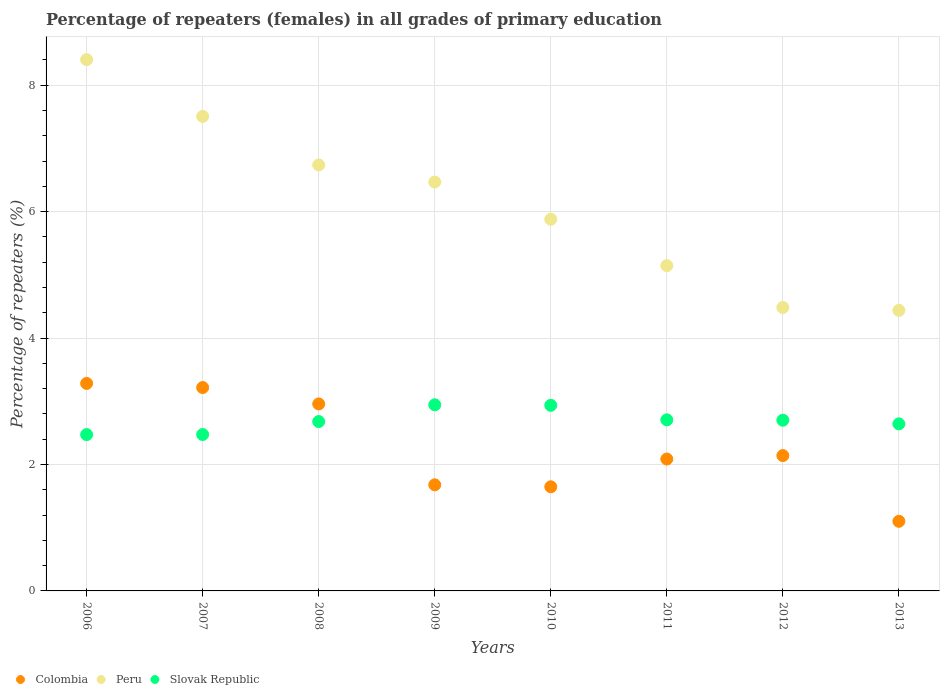How many different coloured dotlines are there?
Provide a short and direct response. 3. What is the percentage of repeaters (females) in Peru in 2008?
Your answer should be very brief. 6.74. Across all years, what is the maximum percentage of repeaters (females) in Slovak Republic?
Provide a short and direct response. 2.94. Across all years, what is the minimum percentage of repeaters (females) in Peru?
Your answer should be very brief. 4.44. In which year was the percentage of repeaters (females) in Peru minimum?
Provide a short and direct response. 2013. What is the total percentage of repeaters (females) in Colombia in the graph?
Make the answer very short. 18.11. What is the difference between the percentage of repeaters (females) in Colombia in 2006 and that in 2011?
Provide a short and direct response. 1.2. What is the difference between the percentage of repeaters (females) in Peru in 2011 and the percentage of repeaters (females) in Colombia in 2013?
Ensure brevity in your answer.  4.04. What is the average percentage of repeaters (females) in Peru per year?
Offer a terse response. 6.13. In the year 2008, what is the difference between the percentage of repeaters (females) in Colombia and percentage of repeaters (females) in Slovak Republic?
Give a very brief answer. 0.28. In how many years, is the percentage of repeaters (females) in Slovak Republic greater than 2.4 %?
Your answer should be very brief. 8. What is the ratio of the percentage of repeaters (females) in Slovak Republic in 2010 to that in 2011?
Offer a very short reply. 1.08. Is the percentage of repeaters (females) in Peru in 2007 less than that in 2008?
Offer a very short reply. No. Is the difference between the percentage of repeaters (females) in Colombia in 2006 and 2008 greater than the difference between the percentage of repeaters (females) in Slovak Republic in 2006 and 2008?
Offer a very short reply. Yes. What is the difference between the highest and the second highest percentage of repeaters (females) in Colombia?
Provide a short and direct response. 0.07. What is the difference between the highest and the lowest percentage of repeaters (females) in Colombia?
Give a very brief answer. 2.18. Is the sum of the percentage of repeaters (females) in Colombia in 2006 and 2013 greater than the maximum percentage of repeaters (females) in Slovak Republic across all years?
Your answer should be very brief. Yes. Is it the case that in every year, the sum of the percentage of repeaters (females) in Peru and percentage of repeaters (females) in Slovak Republic  is greater than the percentage of repeaters (females) in Colombia?
Offer a very short reply. Yes. Is the percentage of repeaters (females) in Peru strictly greater than the percentage of repeaters (females) in Colombia over the years?
Give a very brief answer. Yes. Is the percentage of repeaters (females) in Peru strictly less than the percentage of repeaters (females) in Slovak Republic over the years?
Ensure brevity in your answer.  No. How many dotlines are there?
Provide a succinct answer. 3. What is the difference between two consecutive major ticks on the Y-axis?
Ensure brevity in your answer.  2. What is the title of the graph?
Offer a terse response. Percentage of repeaters (females) in all grades of primary education. What is the label or title of the Y-axis?
Offer a terse response. Percentage of repeaters (%). What is the Percentage of repeaters (%) of Colombia in 2006?
Keep it short and to the point. 3.28. What is the Percentage of repeaters (%) of Peru in 2006?
Your answer should be very brief. 8.4. What is the Percentage of repeaters (%) in Slovak Republic in 2006?
Provide a succinct answer. 2.47. What is the Percentage of repeaters (%) in Colombia in 2007?
Your response must be concise. 3.22. What is the Percentage of repeaters (%) of Peru in 2007?
Your answer should be very brief. 7.51. What is the Percentage of repeaters (%) in Slovak Republic in 2007?
Provide a succinct answer. 2.47. What is the Percentage of repeaters (%) of Colombia in 2008?
Keep it short and to the point. 2.96. What is the Percentage of repeaters (%) in Peru in 2008?
Ensure brevity in your answer.  6.74. What is the Percentage of repeaters (%) of Slovak Republic in 2008?
Your answer should be very brief. 2.68. What is the Percentage of repeaters (%) in Colombia in 2009?
Make the answer very short. 1.68. What is the Percentage of repeaters (%) in Peru in 2009?
Your response must be concise. 6.47. What is the Percentage of repeaters (%) of Slovak Republic in 2009?
Your answer should be compact. 2.94. What is the Percentage of repeaters (%) in Colombia in 2010?
Offer a terse response. 1.65. What is the Percentage of repeaters (%) in Peru in 2010?
Give a very brief answer. 5.88. What is the Percentage of repeaters (%) of Slovak Republic in 2010?
Your answer should be very brief. 2.94. What is the Percentage of repeaters (%) in Colombia in 2011?
Keep it short and to the point. 2.09. What is the Percentage of repeaters (%) in Peru in 2011?
Your answer should be compact. 5.14. What is the Percentage of repeaters (%) of Slovak Republic in 2011?
Ensure brevity in your answer.  2.71. What is the Percentage of repeaters (%) of Colombia in 2012?
Offer a very short reply. 2.14. What is the Percentage of repeaters (%) of Peru in 2012?
Your answer should be very brief. 4.48. What is the Percentage of repeaters (%) in Slovak Republic in 2012?
Your answer should be very brief. 2.7. What is the Percentage of repeaters (%) of Colombia in 2013?
Keep it short and to the point. 1.1. What is the Percentage of repeaters (%) in Peru in 2013?
Your answer should be compact. 4.44. What is the Percentage of repeaters (%) in Slovak Republic in 2013?
Keep it short and to the point. 2.64. Across all years, what is the maximum Percentage of repeaters (%) in Colombia?
Provide a succinct answer. 3.28. Across all years, what is the maximum Percentage of repeaters (%) in Peru?
Provide a short and direct response. 8.4. Across all years, what is the maximum Percentage of repeaters (%) of Slovak Republic?
Your answer should be very brief. 2.94. Across all years, what is the minimum Percentage of repeaters (%) in Colombia?
Provide a short and direct response. 1.1. Across all years, what is the minimum Percentage of repeaters (%) of Peru?
Provide a succinct answer. 4.44. Across all years, what is the minimum Percentage of repeaters (%) in Slovak Republic?
Your answer should be very brief. 2.47. What is the total Percentage of repeaters (%) of Colombia in the graph?
Your response must be concise. 18.11. What is the total Percentage of repeaters (%) in Peru in the graph?
Your answer should be compact. 49.06. What is the total Percentage of repeaters (%) of Slovak Republic in the graph?
Make the answer very short. 21.55. What is the difference between the Percentage of repeaters (%) of Colombia in 2006 and that in 2007?
Offer a terse response. 0.07. What is the difference between the Percentage of repeaters (%) in Peru in 2006 and that in 2007?
Ensure brevity in your answer.  0.9. What is the difference between the Percentage of repeaters (%) of Slovak Republic in 2006 and that in 2007?
Your response must be concise. -0. What is the difference between the Percentage of repeaters (%) in Colombia in 2006 and that in 2008?
Ensure brevity in your answer.  0.32. What is the difference between the Percentage of repeaters (%) in Peru in 2006 and that in 2008?
Offer a very short reply. 1.67. What is the difference between the Percentage of repeaters (%) in Slovak Republic in 2006 and that in 2008?
Provide a short and direct response. -0.21. What is the difference between the Percentage of repeaters (%) in Colombia in 2006 and that in 2009?
Offer a very short reply. 1.6. What is the difference between the Percentage of repeaters (%) of Peru in 2006 and that in 2009?
Give a very brief answer. 1.94. What is the difference between the Percentage of repeaters (%) in Slovak Republic in 2006 and that in 2009?
Your response must be concise. -0.47. What is the difference between the Percentage of repeaters (%) in Colombia in 2006 and that in 2010?
Make the answer very short. 1.64. What is the difference between the Percentage of repeaters (%) of Peru in 2006 and that in 2010?
Offer a very short reply. 2.52. What is the difference between the Percentage of repeaters (%) of Slovak Republic in 2006 and that in 2010?
Provide a succinct answer. -0.46. What is the difference between the Percentage of repeaters (%) of Colombia in 2006 and that in 2011?
Give a very brief answer. 1.2. What is the difference between the Percentage of repeaters (%) of Peru in 2006 and that in 2011?
Keep it short and to the point. 3.26. What is the difference between the Percentage of repeaters (%) in Slovak Republic in 2006 and that in 2011?
Provide a succinct answer. -0.23. What is the difference between the Percentage of repeaters (%) in Colombia in 2006 and that in 2012?
Your answer should be compact. 1.14. What is the difference between the Percentage of repeaters (%) in Peru in 2006 and that in 2012?
Offer a terse response. 3.92. What is the difference between the Percentage of repeaters (%) in Slovak Republic in 2006 and that in 2012?
Your answer should be very brief. -0.23. What is the difference between the Percentage of repeaters (%) in Colombia in 2006 and that in 2013?
Keep it short and to the point. 2.18. What is the difference between the Percentage of repeaters (%) in Peru in 2006 and that in 2013?
Provide a short and direct response. 3.97. What is the difference between the Percentage of repeaters (%) in Slovak Republic in 2006 and that in 2013?
Give a very brief answer. -0.17. What is the difference between the Percentage of repeaters (%) of Colombia in 2007 and that in 2008?
Provide a short and direct response. 0.26. What is the difference between the Percentage of repeaters (%) in Peru in 2007 and that in 2008?
Your response must be concise. 0.77. What is the difference between the Percentage of repeaters (%) of Slovak Republic in 2007 and that in 2008?
Ensure brevity in your answer.  -0.2. What is the difference between the Percentage of repeaters (%) in Colombia in 2007 and that in 2009?
Keep it short and to the point. 1.54. What is the difference between the Percentage of repeaters (%) of Peru in 2007 and that in 2009?
Your answer should be compact. 1.04. What is the difference between the Percentage of repeaters (%) in Slovak Republic in 2007 and that in 2009?
Provide a short and direct response. -0.47. What is the difference between the Percentage of repeaters (%) of Colombia in 2007 and that in 2010?
Your answer should be very brief. 1.57. What is the difference between the Percentage of repeaters (%) of Peru in 2007 and that in 2010?
Your answer should be compact. 1.63. What is the difference between the Percentage of repeaters (%) of Slovak Republic in 2007 and that in 2010?
Provide a short and direct response. -0.46. What is the difference between the Percentage of repeaters (%) in Colombia in 2007 and that in 2011?
Your answer should be compact. 1.13. What is the difference between the Percentage of repeaters (%) of Peru in 2007 and that in 2011?
Ensure brevity in your answer.  2.36. What is the difference between the Percentage of repeaters (%) of Slovak Republic in 2007 and that in 2011?
Ensure brevity in your answer.  -0.23. What is the difference between the Percentage of repeaters (%) of Colombia in 2007 and that in 2012?
Your response must be concise. 1.08. What is the difference between the Percentage of repeaters (%) in Peru in 2007 and that in 2012?
Give a very brief answer. 3.02. What is the difference between the Percentage of repeaters (%) in Slovak Republic in 2007 and that in 2012?
Your answer should be compact. -0.23. What is the difference between the Percentage of repeaters (%) of Colombia in 2007 and that in 2013?
Your response must be concise. 2.12. What is the difference between the Percentage of repeaters (%) in Peru in 2007 and that in 2013?
Provide a succinct answer. 3.07. What is the difference between the Percentage of repeaters (%) in Slovak Republic in 2007 and that in 2013?
Your answer should be very brief. -0.17. What is the difference between the Percentage of repeaters (%) in Colombia in 2008 and that in 2009?
Offer a terse response. 1.28. What is the difference between the Percentage of repeaters (%) in Peru in 2008 and that in 2009?
Offer a very short reply. 0.27. What is the difference between the Percentage of repeaters (%) of Slovak Republic in 2008 and that in 2009?
Your answer should be very brief. -0.26. What is the difference between the Percentage of repeaters (%) of Colombia in 2008 and that in 2010?
Your response must be concise. 1.31. What is the difference between the Percentage of repeaters (%) in Peru in 2008 and that in 2010?
Provide a short and direct response. 0.86. What is the difference between the Percentage of repeaters (%) in Slovak Republic in 2008 and that in 2010?
Offer a very short reply. -0.26. What is the difference between the Percentage of repeaters (%) in Colombia in 2008 and that in 2011?
Provide a succinct answer. 0.87. What is the difference between the Percentage of repeaters (%) of Peru in 2008 and that in 2011?
Your response must be concise. 1.59. What is the difference between the Percentage of repeaters (%) of Slovak Republic in 2008 and that in 2011?
Give a very brief answer. -0.03. What is the difference between the Percentage of repeaters (%) of Colombia in 2008 and that in 2012?
Provide a succinct answer. 0.82. What is the difference between the Percentage of repeaters (%) of Peru in 2008 and that in 2012?
Offer a very short reply. 2.25. What is the difference between the Percentage of repeaters (%) in Slovak Republic in 2008 and that in 2012?
Provide a short and direct response. -0.02. What is the difference between the Percentage of repeaters (%) of Colombia in 2008 and that in 2013?
Your answer should be very brief. 1.86. What is the difference between the Percentage of repeaters (%) in Peru in 2008 and that in 2013?
Ensure brevity in your answer.  2.3. What is the difference between the Percentage of repeaters (%) of Slovak Republic in 2008 and that in 2013?
Offer a very short reply. 0.04. What is the difference between the Percentage of repeaters (%) in Colombia in 2009 and that in 2010?
Your answer should be very brief. 0.03. What is the difference between the Percentage of repeaters (%) in Peru in 2009 and that in 2010?
Your answer should be compact. 0.59. What is the difference between the Percentage of repeaters (%) in Slovak Republic in 2009 and that in 2010?
Your response must be concise. 0.01. What is the difference between the Percentage of repeaters (%) in Colombia in 2009 and that in 2011?
Offer a very short reply. -0.41. What is the difference between the Percentage of repeaters (%) of Peru in 2009 and that in 2011?
Your answer should be very brief. 1.32. What is the difference between the Percentage of repeaters (%) of Slovak Republic in 2009 and that in 2011?
Ensure brevity in your answer.  0.24. What is the difference between the Percentage of repeaters (%) of Colombia in 2009 and that in 2012?
Keep it short and to the point. -0.46. What is the difference between the Percentage of repeaters (%) in Peru in 2009 and that in 2012?
Offer a very short reply. 1.98. What is the difference between the Percentage of repeaters (%) of Slovak Republic in 2009 and that in 2012?
Keep it short and to the point. 0.24. What is the difference between the Percentage of repeaters (%) of Colombia in 2009 and that in 2013?
Make the answer very short. 0.58. What is the difference between the Percentage of repeaters (%) in Peru in 2009 and that in 2013?
Your answer should be very brief. 2.03. What is the difference between the Percentage of repeaters (%) of Slovak Republic in 2009 and that in 2013?
Keep it short and to the point. 0.3. What is the difference between the Percentage of repeaters (%) of Colombia in 2010 and that in 2011?
Provide a succinct answer. -0.44. What is the difference between the Percentage of repeaters (%) in Peru in 2010 and that in 2011?
Your answer should be compact. 0.73. What is the difference between the Percentage of repeaters (%) in Slovak Republic in 2010 and that in 2011?
Keep it short and to the point. 0.23. What is the difference between the Percentage of repeaters (%) in Colombia in 2010 and that in 2012?
Make the answer very short. -0.49. What is the difference between the Percentage of repeaters (%) in Peru in 2010 and that in 2012?
Keep it short and to the point. 1.4. What is the difference between the Percentage of repeaters (%) in Slovak Republic in 2010 and that in 2012?
Give a very brief answer. 0.24. What is the difference between the Percentage of repeaters (%) of Colombia in 2010 and that in 2013?
Ensure brevity in your answer.  0.55. What is the difference between the Percentage of repeaters (%) in Peru in 2010 and that in 2013?
Keep it short and to the point. 1.44. What is the difference between the Percentage of repeaters (%) in Slovak Republic in 2010 and that in 2013?
Provide a succinct answer. 0.29. What is the difference between the Percentage of repeaters (%) of Colombia in 2011 and that in 2012?
Ensure brevity in your answer.  -0.05. What is the difference between the Percentage of repeaters (%) of Peru in 2011 and that in 2012?
Offer a terse response. 0.66. What is the difference between the Percentage of repeaters (%) of Slovak Republic in 2011 and that in 2012?
Offer a terse response. 0.01. What is the difference between the Percentage of repeaters (%) of Peru in 2011 and that in 2013?
Provide a short and direct response. 0.71. What is the difference between the Percentage of repeaters (%) in Slovak Republic in 2011 and that in 2013?
Keep it short and to the point. 0.06. What is the difference between the Percentage of repeaters (%) in Colombia in 2012 and that in 2013?
Your response must be concise. 1.04. What is the difference between the Percentage of repeaters (%) of Peru in 2012 and that in 2013?
Keep it short and to the point. 0.05. What is the difference between the Percentage of repeaters (%) of Slovak Republic in 2012 and that in 2013?
Your answer should be very brief. 0.06. What is the difference between the Percentage of repeaters (%) of Colombia in 2006 and the Percentage of repeaters (%) of Peru in 2007?
Ensure brevity in your answer.  -4.22. What is the difference between the Percentage of repeaters (%) of Colombia in 2006 and the Percentage of repeaters (%) of Slovak Republic in 2007?
Provide a succinct answer. 0.81. What is the difference between the Percentage of repeaters (%) of Peru in 2006 and the Percentage of repeaters (%) of Slovak Republic in 2007?
Provide a short and direct response. 5.93. What is the difference between the Percentage of repeaters (%) in Colombia in 2006 and the Percentage of repeaters (%) in Peru in 2008?
Ensure brevity in your answer.  -3.46. What is the difference between the Percentage of repeaters (%) of Colombia in 2006 and the Percentage of repeaters (%) of Slovak Republic in 2008?
Your response must be concise. 0.6. What is the difference between the Percentage of repeaters (%) in Peru in 2006 and the Percentage of repeaters (%) in Slovak Republic in 2008?
Keep it short and to the point. 5.72. What is the difference between the Percentage of repeaters (%) of Colombia in 2006 and the Percentage of repeaters (%) of Peru in 2009?
Offer a terse response. -3.19. What is the difference between the Percentage of repeaters (%) in Colombia in 2006 and the Percentage of repeaters (%) in Slovak Republic in 2009?
Give a very brief answer. 0.34. What is the difference between the Percentage of repeaters (%) in Peru in 2006 and the Percentage of repeaters (%) in Slovak Republic in 2009?
Provide a short and direct response. 5.46. What is the difference between the Percentage of repeaters (%) in Colombia in 2006 and the Percentage of repeaters (%) in Peru in 2010?
Make the answer very short. -2.6. What is the difference between the Percentage of repeaters (%) in Colombia in 2006 and the Percentage of repeaters (%) in Slovak Republic in 2010?
Make the answer very short. 0.35. What is the difference between the Percentage of repeaters (%) of Peru in 2006 and the Percentage of repeaters (%) of Slovak Republic in 2010?
Provide a succinct answer. 5.47. What is the difference between the Percentage of repeaters (%) of Colombia in 2006 and the Percentage of repeaters (%) of Peru in 2011?
Provide a short and direct response. -1.86. What is the difference between the Percentage of repeaters (%) in Colombia in 2006 and the Percentage of repeaters (%) in Slovak Republic in 2011?
Your answer should be compact. 0.58. What is the difference between the Percentage of repeaters (%) in Peru in 2006 and the Percentage of repeaters (%) in Slovak Republic in 2011?
Keep it short and to the point. 5.7. What is the difference between the Percentage of repeaters (%) in Colombia in 2006 and the Percentage of repeaters (%) in Peru in 2012?
Your response must be concise. -1.2. What is the difference between the Percentage of repeaters (%) of Colombia in 2006 and the Percentage of repeaters (%) of Slovak Republic in 2012?
Keep it short and to the point. 0.58. What is the difference between the Percentage of repeaters (%) of Peru in 2006 and the Percentage of repeaters (%) of Slovak Republic in 2012?
Keep it short and to the point. 5.7. What is the difference between the Percentage of repeaters (%) of Colombia in 2006 and the Percentage of repeaters (%) of Peru in 2013?
Offer a terse response. -1.16. What is the difference between the Percentage of repeaters (%) of Colombia in 2006 and the Percentage of repeaters (%) of Slovak Republic in 2013?
Provide a short and direct response. 0.64. What is the difference between the Percentage of repeaters (%) of Peru in 2006 and the Percentage of repeaters (%) of Slovak Republic in 2013?
Provide a short and direct response. 5.76. What is the difference between the Percentage of repeaters (%) in Colombia in 2007 and the Percentage of repeaters (%) in Peru in 2008?
Your answer should be very brief. -3.52. What is the difference between the Percentage of repeaters (%) in Colombia in 2007 and the Percentage of repeaters (%) in Slovak Republic in 2008?
Offer a terse response. 0.54. What is the difference between the Percentage of repeaters (%) in Peru in 2007 and the Percentage of repeaters (%) in Slovak Republic in 2008?
Provide a succinct answer. 4.83. What is the difference between the Percentage of repeaters (%) of Colombia in 2007 and the Percentage of repeaters (%) of Peru in 2009?
Provide a succinct answer. -3.25. What is the difference between the Percentage of repeaters (%) of Colombia in 2007 and the Percentage of repeaters (%) of Slovak Republic in 2009?
Make the answer very short. 0.27. What is the difference between the Percentage of repeaters (%) in Peru in 2007 and the Percentage of repeaters (%) in Slovak Republic in 2009?
Give a very brief answer. 4.56. What is the difference between the Percentage of repeaters (%) in Colombia in 2007 and the Percentage of repeaters (%) in Peru in 2010?
Provide a succinct answer. -2.66. What is the difference between the Percentage of repeaters (%) in Colombia in 2007 and the Percentage of repeaters (%) in Slovak Republic in 2010?
Offer a very short reply. 0.28. What is the difference between the Percentage of repeaters (%) of Peru in 2007 and the Percentage of repeaters (%) of Slovak Republic in 2010?
Your answer should be compact. 4.57. What is the difference between the Percentage of repeaters (%) of Colombia in 2007 and the Percentage of repeaters (%) of Peru in 2011?
Make the answer very short. -1.93. What is the difference between the Percentage of repeaters (%) in Colombia in 2007 and the Percentage of repeaters (%) in Slovak Republic in 2011?
Provide a short and direct response. 0.51. What is the difference between the Percentage of repeaters (%) of Peru in 2007 and the Percentage of repeaters (%) of Slovak Republic in 2011?
Provide a succinct answer. 4.8. What is the difference between the Percentage of repeaters (%) of Colombia in 2007 and the Percentage of repeaters (%) of Peru in 2012?
Provide a succinct answer. -1.27. What is the difference between the Percentage of repeaters (%) in Colombia in 2007 and the Percentage of repeaters (%) in Slovak Republic in 2012?
Give a very brief answer. 0.52. What is the difference between the Percentage of repeaters (%) of Peru in 2007 and the Percentage of repeaters (%) of Slovak Republic in 2012?
Provide a succinct answer. 4.81. What is the difference between the Percentage of repeaters (%) in Colombia in 2007 and the Percentage of repeaters (%) in Peru in 2013?
Give a very brief answer. -1.22. What is the difference between the Percentage of repeaters (%) in Colombia in 2007 and the Percentage of repeaters (%) in Slovak Republic in 2013?
Make the answer very short. 0.57. What is the difference between the Percentage of repeaters (%) in Peru in 2007 and the Percentage of repeaters (%) in Slovak Republic in 2013?
Make the answer very short. 4.86. What is the difference between the Percentage of repeaters (%) of Colombia in 2008 and the Percentage of repeaters (%) of Peru in 2009?
Your answer should be compact. -3.51. What is the difference between the Percentage of repeaters (%) in Colombia in 2008 and the Percentage of repeaters (%) in Slovak Republic in 2009?
Provide a succinct answer. 0.01. What is the difference between the Percentage of repeaters (%) of Peru in 2008 and the Percentage of repeaters (%) of Slovak Republic in 2009?
Your answer should be compact. 3.79. What is the difference between the Percentage of repeaters (%) in Colombia in 2008 and the Percentage of repeaters (%) in Peru in 2010?
Provide a short and direct response. -2.92. What is the difference between the Percentage of repeaters (%) of Colombia in 2008 and the Percentage of repeaters (%) of Slovak Republic in 2010?
Ensure brevity in your answer.  0.02. What is the difference between the Percentage of repeaters (%) of Peru in 2008 and the Percentage of repeaters (%) of Slovak Republic in 2010?
Provide a short and direct response. 3.8. What is the difference between the Percentage of repeaters (%) of Colombia in 2008 and the Percentage of repeaters (%) of Peru in 2011?
Provide a succinct answer. -2.19. What is the difference between the Percentage of repeaters (%) of Colombia in 2008 and the Percentage of repeaters (%) of Slovak Republic in 2011?
Ensure brevity in your answer.  0.25. What is the difference between the Percentage of repeaters (%) in Peru in 2008 and the Percentage of repeaters (%) in Slovak Republic in 2011?
Make the answer very short. 4.03. What is the difference between the Percentage of repeaters (%) in Colombia in 2008 and the Percentage of repeaters (%) in Peru in 2012?
Offer a terse response. -1.53. What is the difference between the Percentage of repeaters (%) of Colombia in 2008 and the Percentage of repeaters (%) of Slovak Republic in 2012?
Your response must be concise. 0.26. What is the difference between the Percentage of repeaters (%) in Peru in 2008 and the Percentage of repeaters (%) in Slovak Republic in 2012?
Your response must be concise. 4.04. What is the difference between the Percentage of repeaters (%) of Colombia in 2008 and the Percentage of repeaters (%) of Peru in 2013?
Provide a short and direct response. -1.48. What is the difference between the Percentage of repeaters (%) in Colombia in 2008 and the Percentage of repeaters (%) in Slovak Republic in 2013?
Provide a succinct answer. 0.32. What is the difference between the Percentage of repeaters (%) of Peru in 2008 and the Percentage of repeaters (%) of Slovak Republic in 2013?
Your answer should be compact. 4.09. What is the difference between the Percentage of repeaters (%) of Colombia in 2009 and the Percentage of repeaters (%) of Peru in 2010?
Offer a terse response. -4.2. What is the difference between the Percentage of repeaters (%) in Colombia in 2009 and the Percentage of repeaters (%) in Slovak Republic in 2010?
Your answer should be compact. -1.26. What is the difference between the Percentage of repeaters (%) of Peru in 2009 and the Percentage of repeaters (%) of Slovak Republic in 2010?
Keep it short and to the point. 3.53. What is the difference between the Percentage of repeaters (%) of Colombia in 2009 and the Percentage of repeaters (%) of Peru in 2011?
Offer a very short reply. -3.47. What is the difference between the Percentage of repeaters (%) in Colombia in 2009 and the Percentage of repeaters (%) in Slovak Republic in 2011?
Give a very brief answer. -1.03. What is the difference between the Percentage of repeaters (%) of Peru in 2009 and the Percentage of repeaters (%) of Slovak Republic in 2011?
Offer a very short reply. 3.76. What is the difference between the Percentage of repeaters (%) in Colombia in 2009 and the Percentage of repeaters (%) in Peru in 2012?
Give a very brief answer. -2.8. What is the difference between the Percentage of repeaters (%) in Colombia in 2009 and the Percentage of repeaters (%) in Slovak Republic in 2012?
Offer a terse response. -1.02. What is the difference between the Percentage of repeaters (%) in Peru in 2009 and the Percentage of repeaters (%) in Slovak Republic in 2012?
Offer a terse response. 3.77. What is the difference between the Percentage of repeaters (%) in Colombia in 2009 and the Percentage of repeaters (%) in Peru in 2013?
Offer a very short reply. -2.76. What is the difference between the Percentage of repeaters (%) in Colombia in 2009 and the Percentage of repeaters (%) in Slovak Republic in 2013?
Offer a very short reply. -0.96. What is the difference between the Percentage of repeaters (%) in Peru in 2009 and the Percentage of repeaters (%) in Slovak Republic in 2013?
Your answer should be very brief. 3.82. What is the difference between the Percentage of repeaters (%) in Colombia in 2010 and the Percentage of repeaters (%) in Peru in 2011?
Provide a succinct answer. -3.5. What is the difference between the Percentage of repeaters (%) of Colombia in 2010 and the Percentage of repeaters (%) of Slovak Republic in 2011?
Provide a succinct answer. -1.06. What is the difference between the Percentage of repeaters (%) of Peru in 2010 and the Percentage of repeaters (%) of Slovak Republic in 2011?
Ensure brevity in your answer.  3.17. What is the difference between the Percentage of repeaters (%) in Colombia in 2010 and the Percentage of repeaters (%) in Peru in 2012?
Ensure brevity in your answer.  -2.84. What is the difference between the Percentage of repeaters (%) of Colombia in 2010 and the Percentage of repeaters (%) of Slovak Republic in 2012?
Provide a succinct answer. -1.05. What is the difference between the Percentage of repeaters (%) in Peru in 2010 and the Percentage of repeaters (%) in Slovak Republic in 2012?
Ensure brevity in your answer.  3.18. What is the difference between the Percentage of repeaters (%) in Colombia in 2010 and the Percentage of repeaters (%) in Peru in 2013?
Your response must be concise. -2.79. What is the difference between the Percentage of repeaters (%) in Colombia in 2010 and the Percentage of repeaters (%) in Slovak Republic in 2013?
Your answer should be compact. -1. What is the difference between the Percentage of repeaters (%) of Peru in 2010 and the Percentage of repeaters (%) of Slovak Republic in 2013?
Your response must be concise. 3.24. What is the difference between the Percentage of repeaters (%) of Colombia in 2011 and the Percentage of repeaters (%) of Peru in 2012?
Give a very brief answer. -2.4. What is the difference between the Percentage of repeaters (%) in Colombia in 2011 and the Percentage of repeaters (%) in Slovak Republic in 2012?
Your answer should be compact. -0.61. What is the difference between the Percentage of repeaters (%) in Peru in 2011 and the Percentage of repeaters (%) in Slovak Republic in 2012?
Your answer should be very brief. 2.44. What is the difference between the Percentage of repeaters (%) in Colombia in 2011 and the Percentage of repeaters (%) in Peru in 2013?
Your answer should be compact. -2.35. What is the difference between the Percentage of repeaters (%) in Colombia in 2011 and the Percentage of repeaters (%) in Slovak Republic in 2013?
Your response must be concise. -0.56. What is the difference between the Percentage of repeaters (%) in Peru in 2011 and the Percentage of repeaters (%) in Slovak Republic in 2013?
Provide a short and direct response. 2.5. What is the difference between the Percentage of repeaters (%) in Colombia in 2012 and the Percentage of repeaters (%) in Peru in 2013?
Ensure brevity in your answer.  -2.3. What is the difference between the Percentage of repeaters (%) in Colombia in 2012 and the Percentage of repeaters (%) in Slovak Republic in 2013?
Ensure brevity in your answer.  -0.5. What is the difference between the Percentage of repeaters (%) of Peru in 2012 and the Percentage of repeaters (%) of Slovak Republic in 2013?
Give a very brief answer. 1.84. What is the average Percentage of repeaters (%) in Colombia per year?
Provide a short and direct response. 2.26. What is the average Percentage of repeaters (%) in Peru per year?
Your response must be concise. 6.13. What is the average Percentage of repeaters (%) in Slovak Republic per year?
Offer a terse response. 2.69. In the year 2006, what is the difference between the Percentage of repeaters (%) of Colombia and Percentage of repeaters (%) of Peru?
Offer a very short reply. -5.12. In the year 2006, what is the difference between the Percentage of repeaters (%) in Colombia and Percentage of repeaters (%) in Slovak Republic?
Give a very brief answer. 0.81. In the year 2006, what is the difference between the Percentage of repeaters (%) in Peru and Percentage of repeaters (%) in Slovak Republic?
Keep it short and to the point. 5.93. In the year 2007, what is the difference between the Percentage of repeaters (%) in Colombia and Percentage of repeaters (%) in Peru?
Keep it short and to the point. -4.29. In the year 2007, what is the difference between the Percentage of repeaters (%) of Colombia and Percentage of repeaters (%) of Slovak Republic?
Your answer should be very brief. 0.74. In the year 2007, what is the difference between the Percentage of repeaters (%) of Peru and Percentage of repeaters (%) of Slovak Republic?
Your answer should be very brief. 5.03. In the year 2008, what is the difference between the Percentage of repeaters (%) of Colombia and Percentage of repeaters (%) of Peru?
Give a very brief answer. -3.78. In the year 2008, what is the difference between the Percentage of repeaters (%) of Colombia and Percentage of repeaters (%) of Slovak Republic?
Give a very brief answer. 0.28. In the year 2008, what is the difference between the Percentage of repeaters (%) of Peru and Percentage of repeaters (%) of Slovak Republic?
Provide a short and direct response. 4.06. In the year 2009, what is the difference between the Percentage of repeaters (%) in Colombia and Percentage of repeaters (%) in Peru?
Offer a terse response. -4.79. In the year 2009, what is the difference between the Percentage of repeaters (%) in Colombia and Percentage of repeaters (%) in Slovak Republic?
Your answer should be compact. -1.27. In the year 2009, what is the difference between the Percentage of repeaters (%) of Peru and Percentage of repeaters (%) of Slovak Republic?
Your answer should be very brief. 3.52. In the year 2010, what is the difference between the Percentage of repeaters (%) in Colombia and Percentage of repeaters (%) in Peru?
Your response must be concise. -4.23. In the year 2010, what is the difference between the Percentage of repeaters (%) of Colombia and Percentage of repeaters (%) of Slovak Republic?
Your answer should be very brief. -1.29. In the year 2010, what is the difference between the Percentage of repeaters (%) of Peru and Percentage of repeaters (%) of Slovak Republic?
Keep it short and to the point. 2.94. In the year 2011, what is the difference between the Percentage of repeaters (%) of Colombia and Percentage of repeaters (%) of Peru?
Provide a short and direct response. -3.06. In the year 2011, what is the difference between the Percentage of repeaters (%) of Colombia and Percentage of repeaters (%) of Slovak Republic?
Offer a very short reply. -0.62. In the year 2011, what is the difference between the Percentage of repeaters (%) of Peru and Percentage of repeaters (%) of Slovak Republic?
Offer a very short reply. 2.44. In the year 2012, what is the difference between the Percentage of repeaters (%) of Colombia and Percentage of repeaters (%) of Peru?
Give a very brief answer. -2.34. In the year 2012, what is the difference between the Percentage of repeaters (%) in Colombia and Percentage of repeaters (%) in Slovak Republic?
Give a very brief answer. -0.56. In the year 2012, what is the difference between the Percentage of repeaters (%) of Peru and Percentage of repeaters (%) of Slovak Republic?
Keep it short and to the point. 1.78. In the year 2013, what is the difference between the Percentage of repeaters (%) in Colombia and Percentage of repeaters (%) in Peru?
Offer a terse response. -3.34. In the year 2013, what is the difference between the Percentage of repeaters (%) of Colombia and Percentage of repeaters (%) of Slovak Republic?
Give a very brief answer. -1.54. In the year 2013, what is the difference between the Percentage of repeaters (%) of Peru and Percentage of repeaters (%) of Slovak Republic?
Provide a short and direct response. 1.8. What is the ratio of the Percentage of repeaters (%) of Colombia in 2006 to that in 2007?
Ensure brevity in your answer.  1.02. What is the ratio of the Percentage of repeaters (%) of Peru in 2006 to that in 2007?
Make the answer very short. 1.12. What is the ratio of the Percentage of repeaters (%) of Colombia in 2006 to that in 2008?
Make the answer very short. 1.11. What is the ratio of the Percentage of repeaters (%) in Peru in 2006 to that in 2008?
Your answer should be very brief. 1.25. What is the ratio of the Percentage of repeaters (%) in Slovak Republic in 2006 to that in 2008?
Make the answer very short. 0.92. What is the ratio of the Percentage of repeaters (%) of Colombia in 2006 to that in 2009?
Offer a very short reply. 1.96. What is the ratio of the Percentage of repeaters (%) in Peru in 2006 to that in 2009?
Make the answer very short. 1.3. What is the ratio of the Percentage of repeaters (%) of Slovak Republic in 2006 to that in 2009?
Offer a terse response. 0.84. What is the ratio of the Percentage of repeaters (%) of Colombia in 2006 to that in 2010?
Provide a succinct answer. 1.99. What is the ratio of the Percentage of repeaters (%) in Peru in 2006 to that in 2010?
Give a very brief answer. 1.43. What is the ratio of the Percentage of repeaters (%) in Slovak Republic in 2006 to that in 2010?
Keep it short and to the point. 0.84. What is the ratio of the Percentage of repeaters (%) of Colombia in 2006 to that in 2011?
Keep it short and to the point. 1.57. What is the ratio of the Percentage of repeaters (%) of Peru in 2006 to that in 2011?
Your response must be concise. 1.63. What is the ratio of the Percentage of repeaters (%) of Slovak Republic in 2006 to that in 2011?
Your answer should be very brief. 0.91. What is the ratio of the Percentage of repeaters (%) of Colombia in 2006 to that in 2012?
Provide a succinct answer. 1.53. What is the ratio of the Percentage of repeaters (%) of Peru in 2006 to that in 2012?
Keep it short and to the point. 1.87. What is the ratio of the Percentage of repeaters (%) in Slovak Republic in 2006 to that in 2012?
Make the answer very short. 0.92. What is the ratio of the Percentage of repeaters (%) of Colombia in 2006 to that in 2013?
Your response must be concise. 2.98. What is the ratio of the Percentage of repeaters (%) of Peru in 2006 to that in 2013?
Offer a very short reply. 1.89. What is the ratio of the Percentage of repeaters (%) of Slovak Republic in 2006 to that in 2013?
Ensure brevity in your answer.  0.94. What is the ratio of the Percentage of repeaters (%) of Colombia in 2007 to that in 2008?
Keep it short and to the point. 1.09. What is the ratio of the Percentage of repeaters (%) in Peru in 2007 to that in 2008?
Provide a short and direct response. 1.11. What is the ratio of the Percentage of repeaters (%) in Slovak Republic in 2007 to that in 2008?
Your answer should be compact. 0.92. What is the ratio of the Percentage of repeaters (%) of Colombia in 2007 to that in 2009?
Your response must be concise. 1.92. What is the ratio of the Percentage of repeaters (%) in Peru in 2007 to that in 2009?
Keep it short and to the point. 1.16. What is the ratio of the Percentage of repeaters (%) in Slovak Republic in 2007 to that in 2009?
Give a very brief answer. 0.84. What is the ratio of the Percentage of repeaters (%) in Colombia in 2007 to that in 2010?
Provide a short and direct response. 1.95. What is the ratio of the Percentage of repeaters (%) of Peru in 2007 to that in 2010?
Ensure brevity in your answer.  1.28. What is the ratio of the Percentage of repeaters (%) of Slovak Republic in 2007 to that in 2010?
Your answer should be very brief. 0.84. What is the ratio of the Percentage of repeaters (%) of Colombia in 2007 to that in 2011?
Your response must be concise. 1.54. What is the ratio of the Percentage of repeaters (%) in Peru in 2007 to that in 2011?
Provide a succinct answer. 1.46. What is the ratio of the Percentage of repeaters (%) in Slovak Republic in 2007 to that in 2011?
Offer a very short reply. 0.91. What is the ratio of the Percentage of repeaters (%) of Colombia in 2007 to that in 2012?
Your answer should be very brief. 1.5. What is the ratio of the Percentage of repeaters (%) in Peru in 2007 to that in 2012?
Your answer should be compact. 1.67. What is the ratio of the Percentage of repeaters (%) in Slovak Republic in 2007 to that in 2012?
Offer a very short reply. 0.92. What is the ratio of the Percentage of repeaters (%) of Colombia in 2007 to that in 2013?
Provide a succinct answer. 2.92. What is the ratio of the Percentage of repeaters (%) of Peru in 2007 to that in 2013?
Offer a very short reply. 1.69. What is the ratio of the Percentage of repeaters (%) in Slovak Republic in 2007 to that in 2013?
Your response must be concise. 0.94. What is the ratio of the Percentage of repeaters (%) of Colombia in 2008 to that in 2009?
Make the answer very short. 1.76. What is the ratio of the Percentage of repeaters (%) of Peru in 2008 to that in 2009?
Provide a succinct answer. 1.04. What is the ratio of the Percentage of repeaters (%) of Slovak Republic in 2008 to that in 2009?
Offer a very short reply. 0.91. What is the ratio of the Percentage of repeaters (%) in Colombia in 2008 to that in 2010?
Keep it short and to the point. 1.8. What is the ratio of the Percentage of repeaters (%) of Peru in 2008 to that in 2010?
Offer a terse response. 1.15. What is the ratio of the Percentage of repeaters (%) in Slovak Republic in 2008 to that in 2010?
Give a very brief answer. 0.91. What is the ratio of the Percentage of repeaters (%) in Colombia in 2008 to that in 2011?
Your response must be concise. 1.42. What is the ratio of the Percentage of repeaters (%) in Peru in 2008 to that in 2011?
Ensure brevity in your answer.  1.31. What is the ratio of the Percentage of repeaters (%) of Colombia in 2008 to that in 2012?
Offer a terse response. 1.38. What is the ratio of the Percentage of repeaters (%) in Peru in 2008 to that in 2012?
Provide a succinct answer. 1.5. What is the ratio of the Percentage of repeaters (%) of Slovak Republic in 2008 to that in 2012?
Offer a very short reply. 0.99. What is the ratio of the Percentage of repeaters (%) of Colombia in 2008 to that in 2013?
Your answer should be very brief. 2.69. What is the ratio of the Percentage of repeaters (%) in Peru in 2008 to that in 2013?
Offer a very short reply. 1.52. What is the ratio of the Percentage of repeaters (%) of Slovak Republic in 2008 to that in 2013?
Your response must be concise. 1.01. What is the ratio of the Percentage of repeaters (%) in Colombia in 2009 to that in 2010?
Give a very brief answer. 1.02. What is the ratio of the Percentage of repeaters (%) of Peru in 2009 to that in 2010?
Offer a very short reply. 1.1. What is the ratio of the Percentage of repeaters (%) of Colombia in 2009 to that in 2011?
Make the answer very short. 0.8. What is the ratio of the Percentage of repeaters (%) of Peru in 2009 to that in 2011?
Your answer should be compact. 1.26. What is the ratio of the Percentage of repeaters (%) of Slovak Republic in 2009 to that in 2011?
Offer a very short reply. 1.09. What is the ratio of the Percentage of repeaters (%) of Colombia in 2009 to that in 2012?
Ensure brevity in your answer.  0.78. What is the ratio of the Percentage of repeaters (%) in Peru in 2009 to that in 2012?
Provide a succinct answer. 1.44. What is the ratio of the Percentage of repeaters (%) of Slovak Republic in 2009 to that in 2012?
Ensure brevity in your answer.  1.09. What is the ratio of the Percentage of repeaters (%) of Colombia in 2009 to that in 2013?
Offer a terse response. 1.52. What is the ratio of the Percentage of repeaters (%) in Peru in 2009 to that in 2013?
Ensure brevity in your answer.  1.46. What is the ratio of the Percentage of repeaters (%) of Slovak Republic in 2009 to that in 2013?
Make the answer very short. 1.11. What is the ratio of the Percentage of repeaters (%) of Colombia in 2010 to that in 2011?
Your answer should be very brief. 0.79. What is the ratio of the Percentage of repeaters (%) of Peru in 2010 to that in 2011?
Ensure brevity in your answer.  1.14. What is the ratio of the Percentage of repeaters (%) in Slovak Republic in 2010 to that in 2011?
Ensure brevity in your answer.  1.08. What is the ratio of the Percentage of repeaters (%) in Colombia in 2010 to that in 2012?
Provide a succinct answer. 0.77. What is the ratio of the Percentage of repeaters (%) in Peru in 2010 to that in 2012?
Your response must be concise. 1.31. What is the ratio of the Percentage of repeaters (%) in Slovak Republic in 2010 to that in 2012?
Your answer should be compact. 1.09. What is the ratio of the Percentage of repeaters (%) in Colombia in 2010 to that in 2013?
Keep it short and to the point. 1.5. What is the ratio of the Percentage of repeaters (%) in Peru in 2010 to that in 2013?
Make the answer very short. 1.32. What is the ratio of the Percentage of repeaters (%) of Slovak Republic in 2010 to that in 2013?
Make the answer very short. 1.11. What is the ratio of the Percentage of repeaters (%) in Colombia in 2011 to that in 2012?
Keep it short and to the point. 0.97. What is the ratio of the Percentage of repeaters (%) in Peru in 2011 to that in 2012?
Your answer should be very brief. 1.15. What is the ratio of the Percentage of repeaters (%) of Slovak Republic in 2011 to that in 2012?
Make the answer very short. 1. What is the ratio of the Percentage of repeaters (%) of Colombia in 2011 to that in 2013?
Keep it short and to the point. 1.89. What is the ratio of the Percentage of repeaters (%) of Peru in 2011 to that in 2013?
Your answer should be very brief. 1.16. What is the ratio of the Percentage of repeaters (%) in Slovak Republic in 2011 to that in 2013?
Provide a short and direct response. 1.02. What is the ratio of the Percentage of repeaters (%) of Colombia in 2012 to that in 2013?
Keep it short and to the point. 1.94. What is the ratio of the Percentage of repeaters (%) of Peru in 2012 to that in 2013?
Offer a very short reply. 1.01. What is the ratio of the Percentage of repeaters (%) of Slovak Republic in 2012 to that in 2013?
Your answer should be compact. 1.02. What is the difference between the highest and the second highest Percentage of repeaters (%) in Colombia?
Offer a terse response. 0.07. What is the difference between the highest and the second highest Percentage of repeaters (%) in Peru?
Your answer should be compact. 0.9. What is the difference between the highest and the second highest Percentage of repeaters (%) of Slovak Republic?
Give a very brief answer. 0.01. What is the difference between the highest and the lowest Percentage of repeaters (%) of Colombia?
Keep it short and to the point. 2.18. What is the difference between the highest and the lowest Percentage of repeaters (%) of Peru?
Provide a short and direct response. 3.97. What is the difference between the highest and the lowest Percentage of repeaters (%) in Slovak Republic?
Make the answer very short. 0.47. 